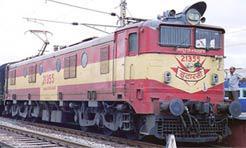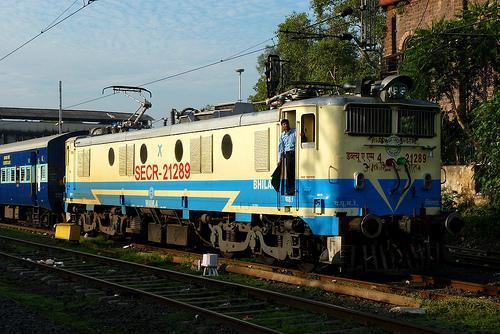The first image is the image on the left, the second image is the image on the right. Analyze the images presented: Is the assertion "Both trains are moving toward the right." valid? Answer yes or no. Yes. The first image is the image on the left, the second image is the image on the right. Examine the images to the left and right. Is the description "In one image a train locomotive at the front is painted in different two-tone colors than the one or more train cars that are behind it." accurate? Answer yes or no. Yes. 